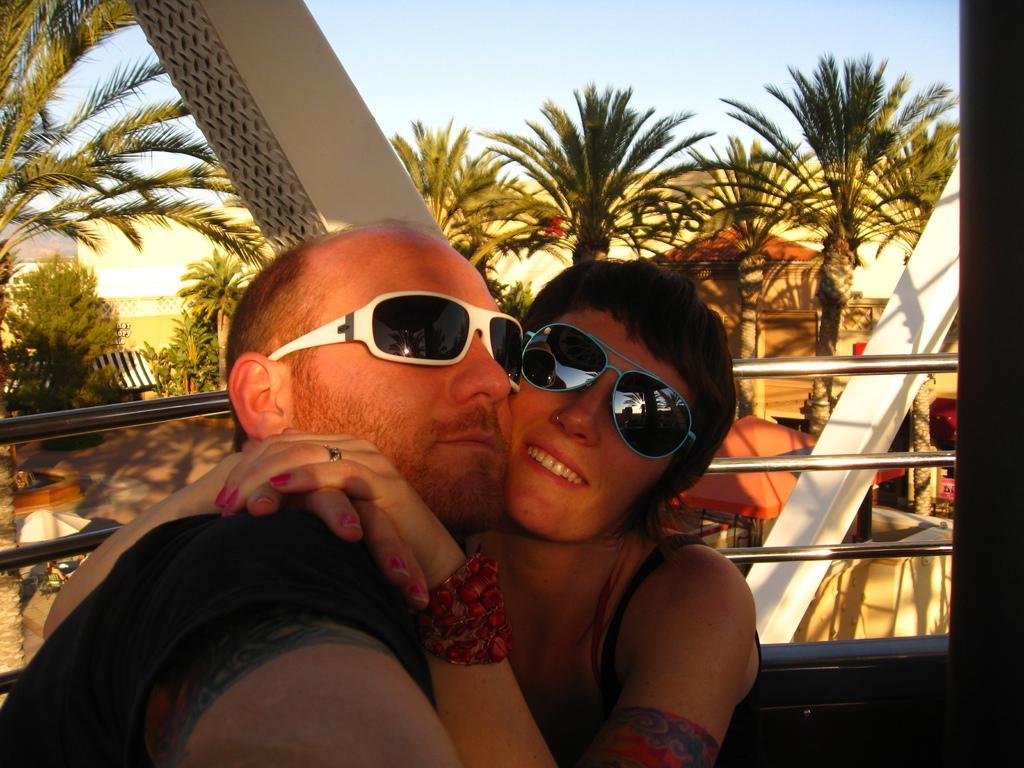Please provide a concise description of this image. In this picture I can see a man and a woman at the bottom, behind them there is a railing, in the background there are trees and buildings. At the top there is the sky, 